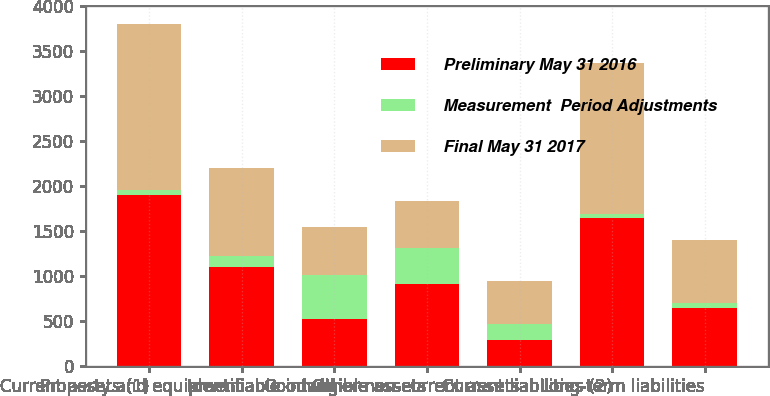Convert chart. <chart><loc_0><loc_0><loc_500><loc_500><stacked_bar_chart><ecel><fcel>Current assets (1)<fcel>Property and equipment<fcel>Goodwill<fcel>Identifiable intangible assets<fcel>Other non-current assets<fcel>Current liabilities (2)<fcel>Long-term liabilities<nl><fcel>Preliminary May 31 2016<fcel>1905<fcel>1104<fcel>530<fcel>920<fcel>289<fcel>1644<fcel>644<nl><fcel>Measurement  Period Adjustments<fcel>53<fcel>124<fcel>488<fcel>390<fcel>183<fcel>44<fcel>60<nl><fcel>Final May 31 2017<fcel>1852<fcel>980<fcel>530<fcel>530<fcel>472<fcel>1688<fcel>704<nl></chart> 